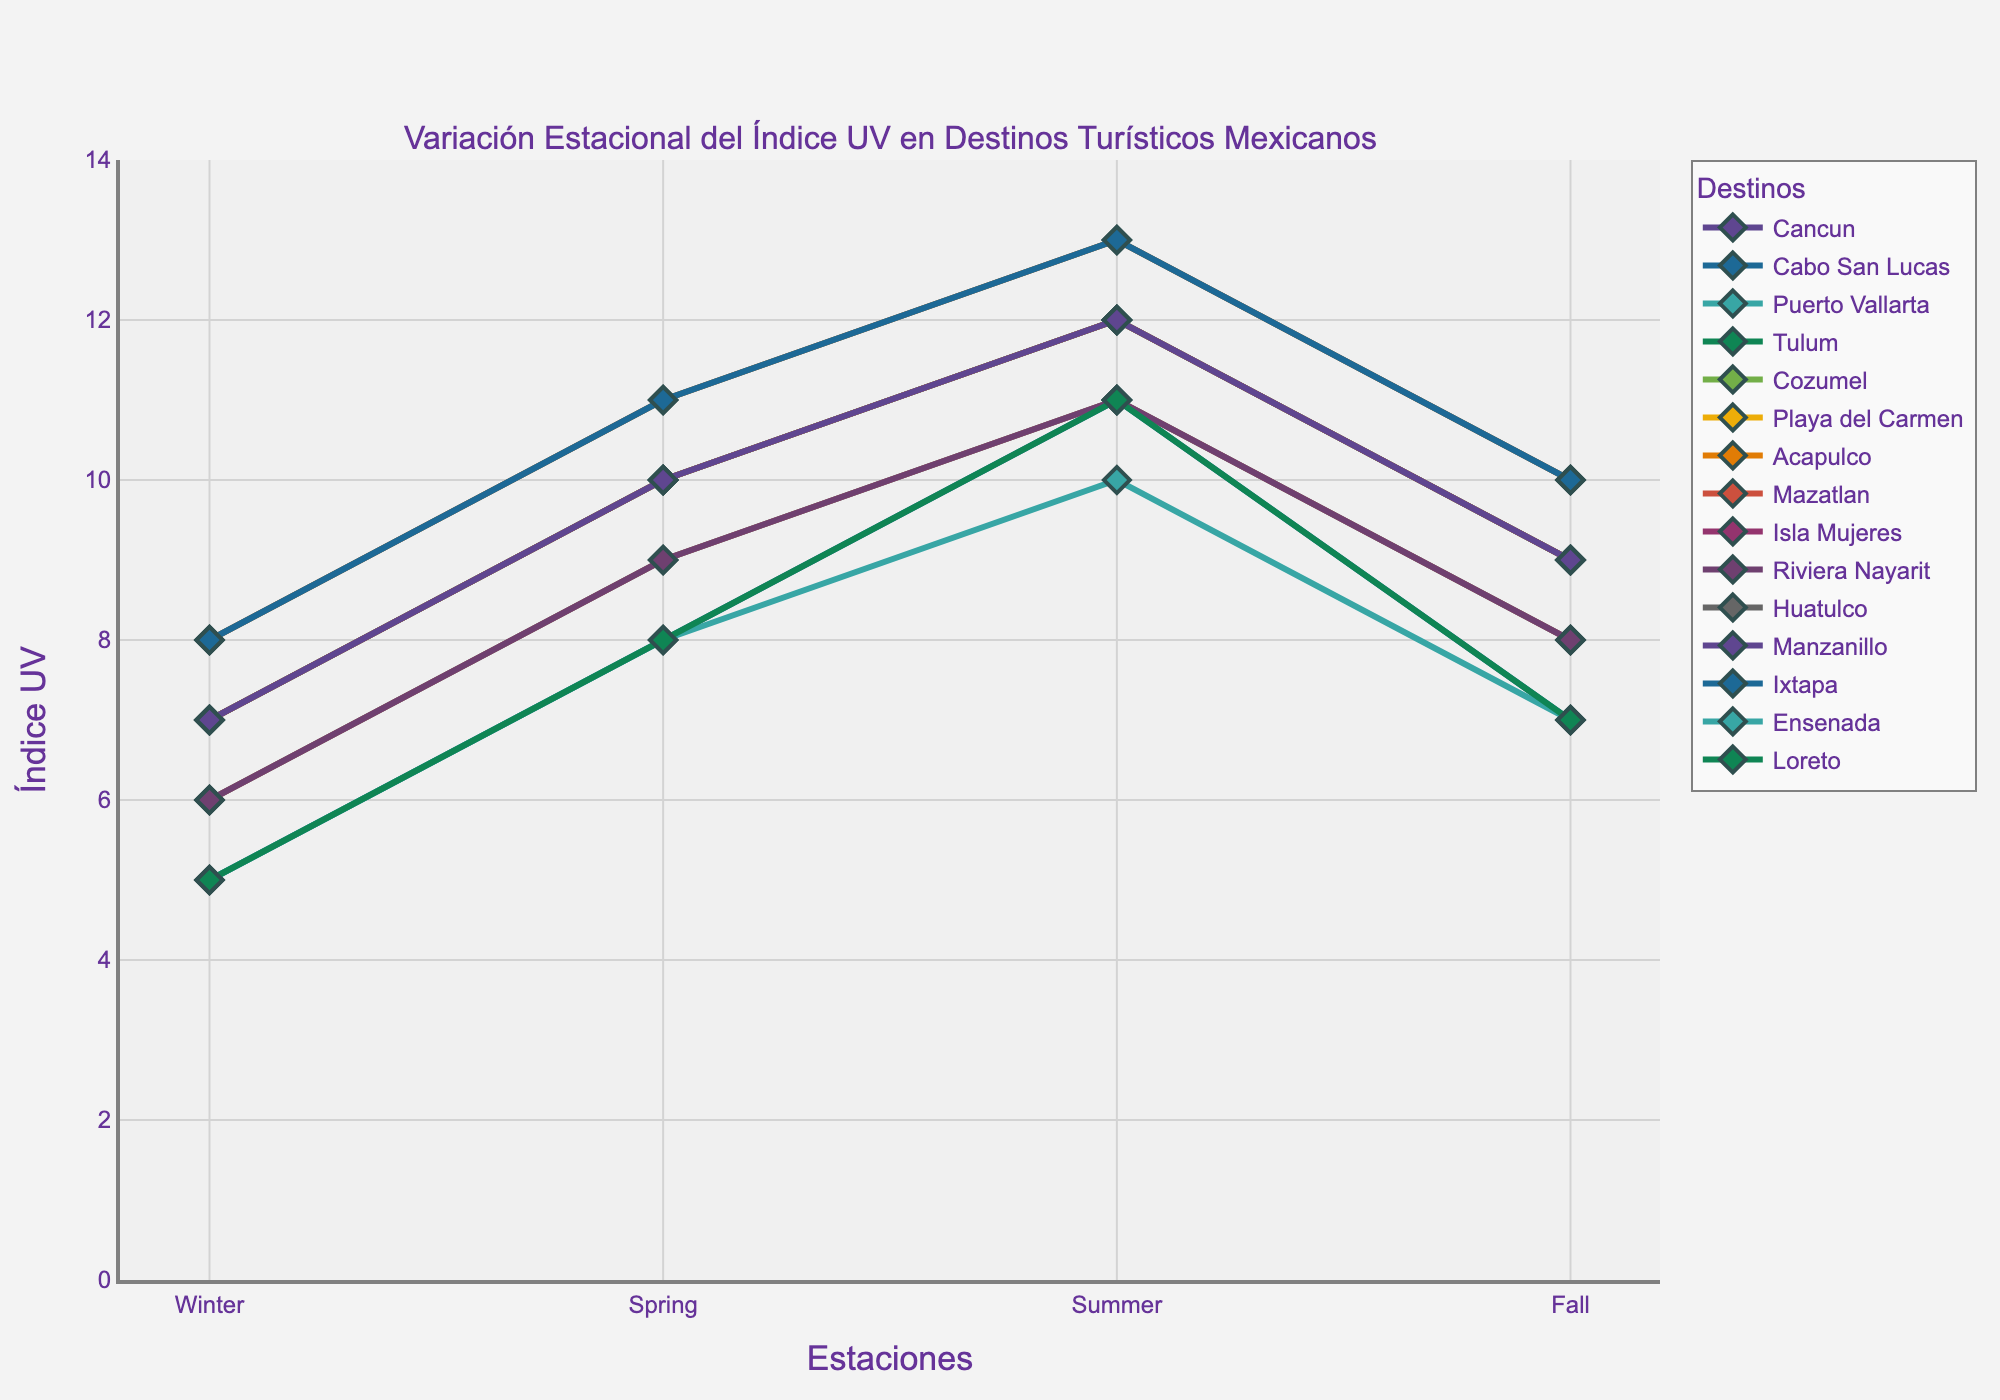Which destination has the highest UV index in Summer? To find the destination with the highest UV index in Summer, refer to the Summer column and identify the highest value.
Answer: Acapulco, Huatulco, and Ixtapa (13) Comparing Winter UV index values, which destination has the lowest UV index? Examine the Winter column to identify the destination with the lowest UV index.
Answer: Cabo San Lucas, Ensenada, and Loreto (5) What's the average UV index in Fall across all destinations? Sum the Fall UV index values for all destinations and divide by the number of destinations (15). (9 + 7 + 8 + 9 + 9 + 9 + 10 + 8 + 9 + 8 + 10 + 9 + 10 + 7 + 7) / 15 = 10
Answer: 8.6 Which seasons show the highest UV index for Playa del Carmen? Check the UV index values for Playa del Carmen across all seasons and identify the highest values.
Answer: Summer and Fall (12) Compare the UV index in Winter and Fall for Mazatlan. Which season has a higher UV index? Look at Mazatlan's UV index values for Winter and Fall and compare them. Winter: 6, Fall: 8
Answer: Fall What's the difference in UV index between Spring and Winter for Acapulco? Subtract the UV index value for Winter from Spring for Acapulco. Spring: 11, Winter: 8, hence, 11 - 8
Answer: 3 Identify two destinations with the same UV index values for all seasons. Check if any two destinations share the exact UV index values across all seasons.
Answer: Tulum and Playa del Carmen How does the UV index in Summer compare between Ensenada and Riviera Nayarit? Compare the Summer UV index values for Ensenada (10) and Riviera Nayarit (11).
Answer: Riviera Nayarit has a higher UV index Which destination has the highest UV index in Winter, and what is its value? Refer to the Winter column to find the highest UV value and the corresponding destination.
Answer: Acapulco, Huatulco, and Ixtapa (8) For Puerto Vallarta, what is the range of UV index values across all seasons? Find the difference between the highest and lowest UV index values for Puerto Vallarta. The highest value is in Summer (11) and the lowest in Winter (6), so 11 - 6
Answer: 5 